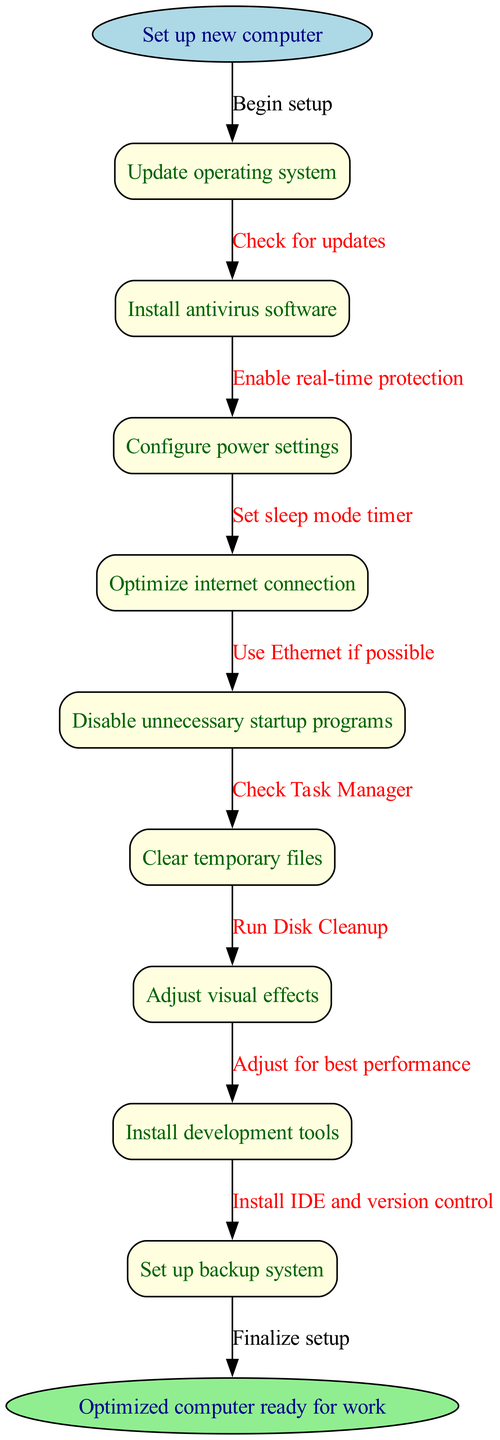What is the starting point of the flowchart? The flowchart begins with the instruction "Set up new computer," which is indicated at the top of the diagram as the starting node.
Answer: Set up new computer How many nodes are there in total? The flowchart contains a total of 10 nodes, which include the starting point, intermediate nodes, and the ending node. Counting each one gives us 1 (start) + 8 (intermediate nodes) + 1 (end) = 10.
Answer: 10 What is the last step before finalizing the setup? The last step before reaching the end node is "Set up backup system." This is the final task denoted in the flowchart before it transitions to the end.
Answer: Set up backup system Which node follows 'Update operating system'? The node that follows 'Update operating system' is 'Install antivirus software,' establishing a direct connection in the flow of tasks outlined in the diagram.
Answer: Install antivirus software What action is represented by the edge from 'Configure power settings' to the next node? The action represented by this edge is "Set sleep mode timer," linking the task of configuring power settings to the subsequent action needed in the flowchart.
Answer: Set sleep mode timer Which task is linked to optimizing the internet connection? The task linked to optimizing the internet connection is "Use Ethernet if possible," which is the instruction that directly follows this optimization step in the flowchart.
Answer: Use Ethernet if possible What color represents the end node? The end node is represented by the color light green, as seen in the diagram's design, distinguishing it from the other nodes.
Answer: Light green Which two nodes are connected by the edge labeled 'Check for updates'? The edge labeled 'Check for updates' connects the start node 'Set up new computer' to the next node 'Update operating system', indicating the initial action after starting the setup.
Answer: Set up new computer and Update operating system What type of software is to be installed after optimizing the internet connection? The type of software to be installed after optimizing the internet connection is 'development tools,' as indicated in the sequence of tasks in the diagram.
Answer: Development tools 